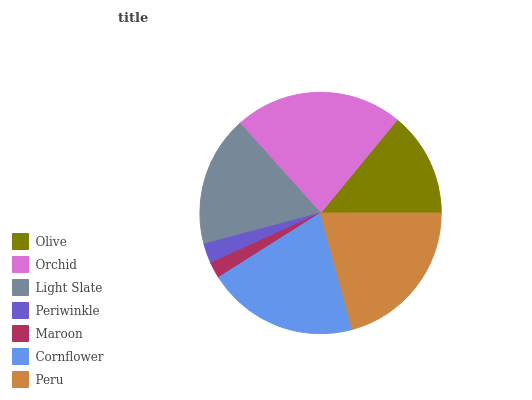Is Maroon the minimum?
Answer yes or no. Yes. Is Orchid the maximum?
Answer yes or no. Yes. Is Light Slate the minimum?
Answer yes or no. No. Is Light Slate the maximum?
Answer yes or no. No. Is Orchid greater than Light Slate?
Answer yes or no. Yes. Is Light Slate less than Orchid?
Answer yes or no. Yes. Is Light Slate greater than Orchid?
Answer yes or no. No. Is Orchid less than Light Slate?
Answer yes or no. No. Is Light Slate the high median?
Answer yes or no. Yes. Is Light Slate the low median?
Answer yes or no. Yes. Is Cornflower the high median?
Answer yes or no. No. Is Maroon the low median?
Answer yes or no. No. 